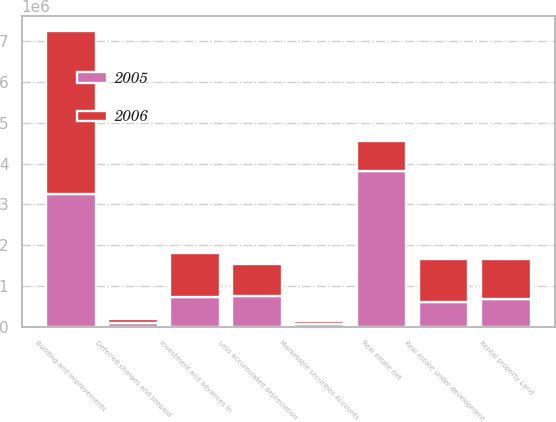Convert chart to OTSL. <chart><loc_0><loc_0><loc_500><loc_500><stacked_bar_chart><ecel><fcel>Rental property Land<fcel>Building and improvements<fcel>Less accumulated depreciation<fcel>Real estate under development<fcel>Real estate net<fcel>Investment and advances in<fcel>Marketable securities Accounts<fcel>Deferred charges and prepaid<nl><fcel>2006<fcel>978819<fcel>3.98452e+06<fcel>806670<fcel>1.03798e+06<fcel>740127<fcel>1.06792e+06<fcel>83418<fcel>95163<nl><fcel>2005<fcel>686123<fcel>3.26316e+06<fcel>740127<fcel>611121<fcel>3.82028e+06<fcel>735648<fcel>64329<fcel>84022<nl></chart> 